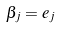<formula> <loc_0><loc_0><loc_500><loc_500>\beta _ { j } = e _ { j }</formula> 